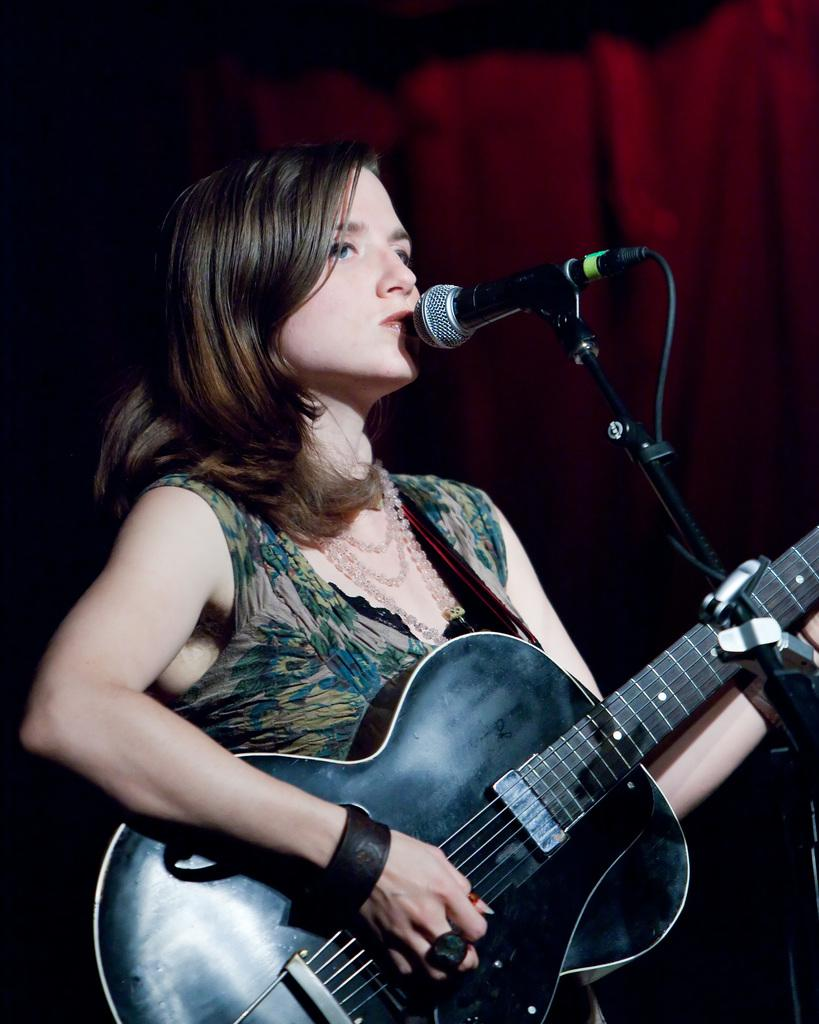Who is the main subject in the image? There is a woman in the image. Where is the woman positioned in the image? The woman is standing in the center. What is the woman holding in the image? The woman is holding a guitar. What is the woman doing in the image? The woman is singing on a microphone. What can be seen in the background of the image? There is a red color curtain in the background. What type of crime is being committed by the sheep in the image? There are no sheep present in the image, so no crime can be committed by them. 